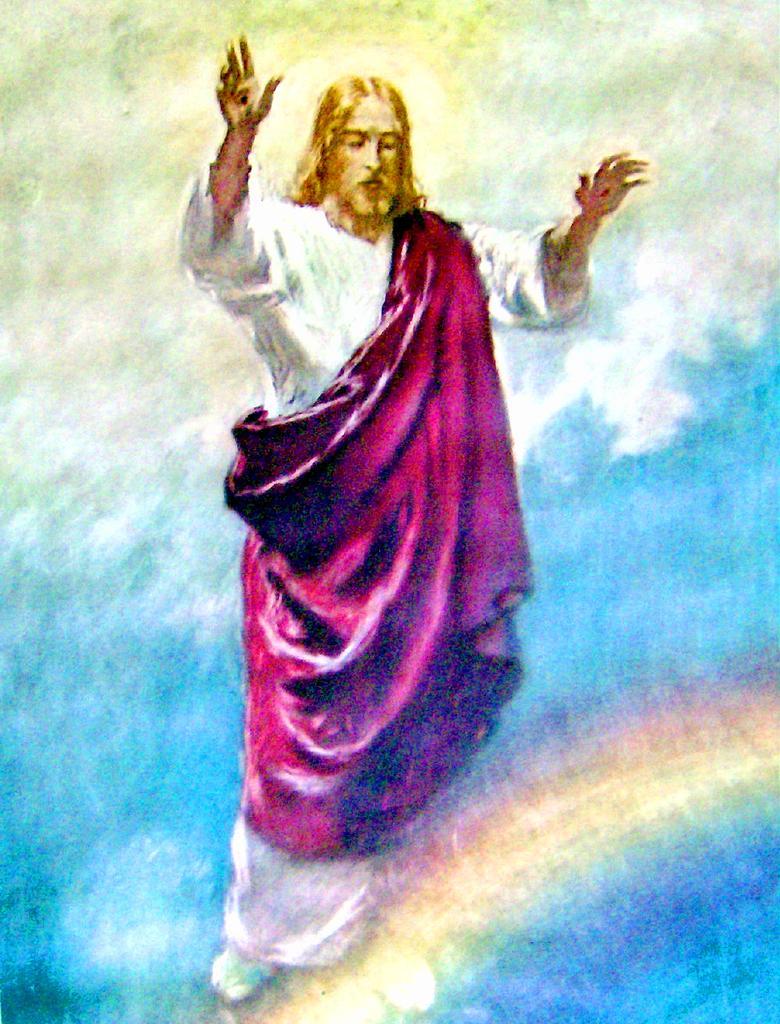Describe this image in one or two sentences. In this picture we can see a painting, it is a painting of Jesus. 